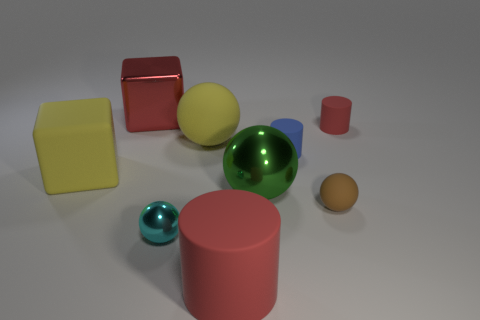Is there anything else that has the same size as the yellow rubber cube?
Keep it short and to the point. Yes. Does the large rubber object in front of the tiny cyan object have the same color as the large rubber sphere?
Your answer should be very brief. No. How many balls are either large yellow things or cyan things?
Your answer should be compact. 2. The big rubber thing in front of the yellow matte cube has what shape?
Your answer should be very brief. Cylinder. What color is the matte cylinder that is in front of the shiny object in front of the large shiny ball that is behind the large red matte thing?
Your response must be concise. Red. Does the big yellow block have the same material as the large green sphere?
Keep it short and to the point. No. How many red objects are either big things or big cylinders?
Give a very brief answer. 2. How many shiny spheres are behind the small cyan shiny object?
Give a very brief answer. 1. Are there more large yellow objects than cylinders?
Keep it short and to the point. No. There is a big metal object that is on the left side of the red matte object in front of the large matte ball; what is its shape?
Offer a terse response. Cube. 